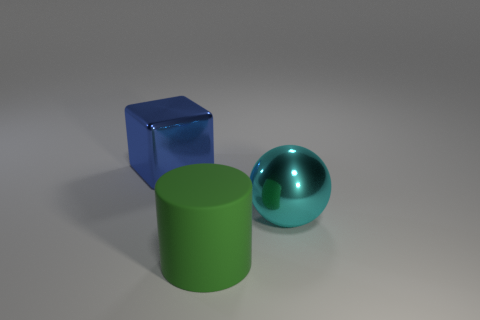Add 1 blue rubber objects. How many objects exist? 4 Subtract all cylinders. How many objects are left? 2 Add 3 cyan metal objects. How many cyan metal objects exist? 4 Subtract 0 brown blocks. How many objects are left? 3 Subtract all cyan matte cubes. Subtract all green matte things. How many objects are left? 2 Add 3 large blue cubes. How many large blue cubes are left? 4 